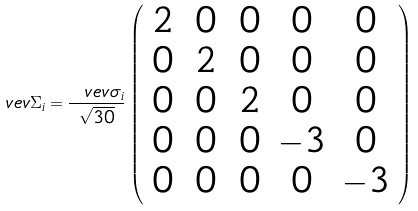Convert formula to latex. <formula><loc_0><loc_0><loc_500><loc_500>\ v e v { \Sigma _ { i } } = \frac { \ v e v { \sigma _ { i } } } { \sqrt { 3 0 } } \left ( \begin{array} { c c c c c } 2 \, & 0 \, & 0 & 0 & 0 \\ 0 \, & 2 \, & 0 & 0 & 0 \\ 0 \, & 0 \, & 2 & 0 & 0 \\ 0 \, & 0 \, & 0 & - 3 & 0 \\ 0 \, & 0 \, & 0 & 0 & - 3 \end{array} \right )</formula> 